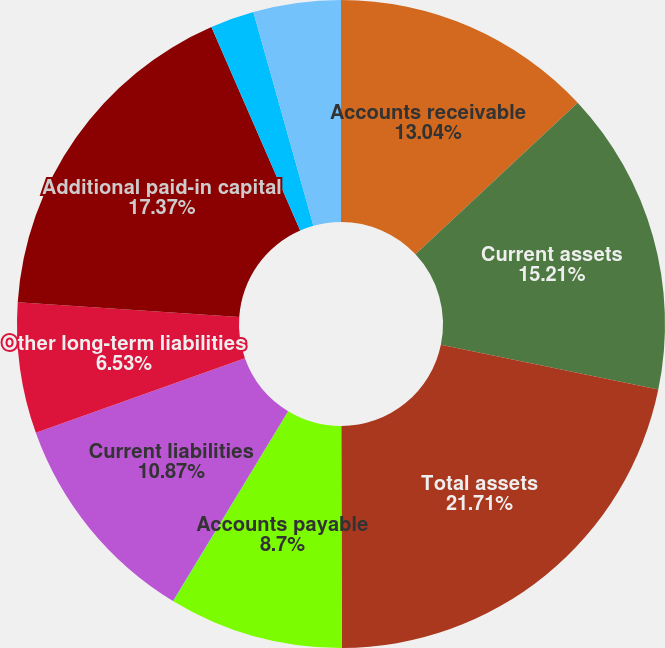Convert chart. <chart><loc_0><loc_0><loc_500><loc_500><pie_chart><fcel>Accounts receivable<fcel>Current assets<fcel>Total assets<fcel>Accounts payable<fcel>Other current liabilities<fcel>Current liabilities<fcel>Other long-term liabilities<fcel>Additional paid-in capital<fcel>Accumulated other<fcel>Retained earnings (deficit)<nl><fcel>13.04%<fcel>15.21%<fcel>21.72%<fcel>8.7%<fcel>0.02%<fcel>10.87%<fcel>6.53%<fcel>17.38%<fcel>2.19%<fcel>4.36%<nl></chart> 